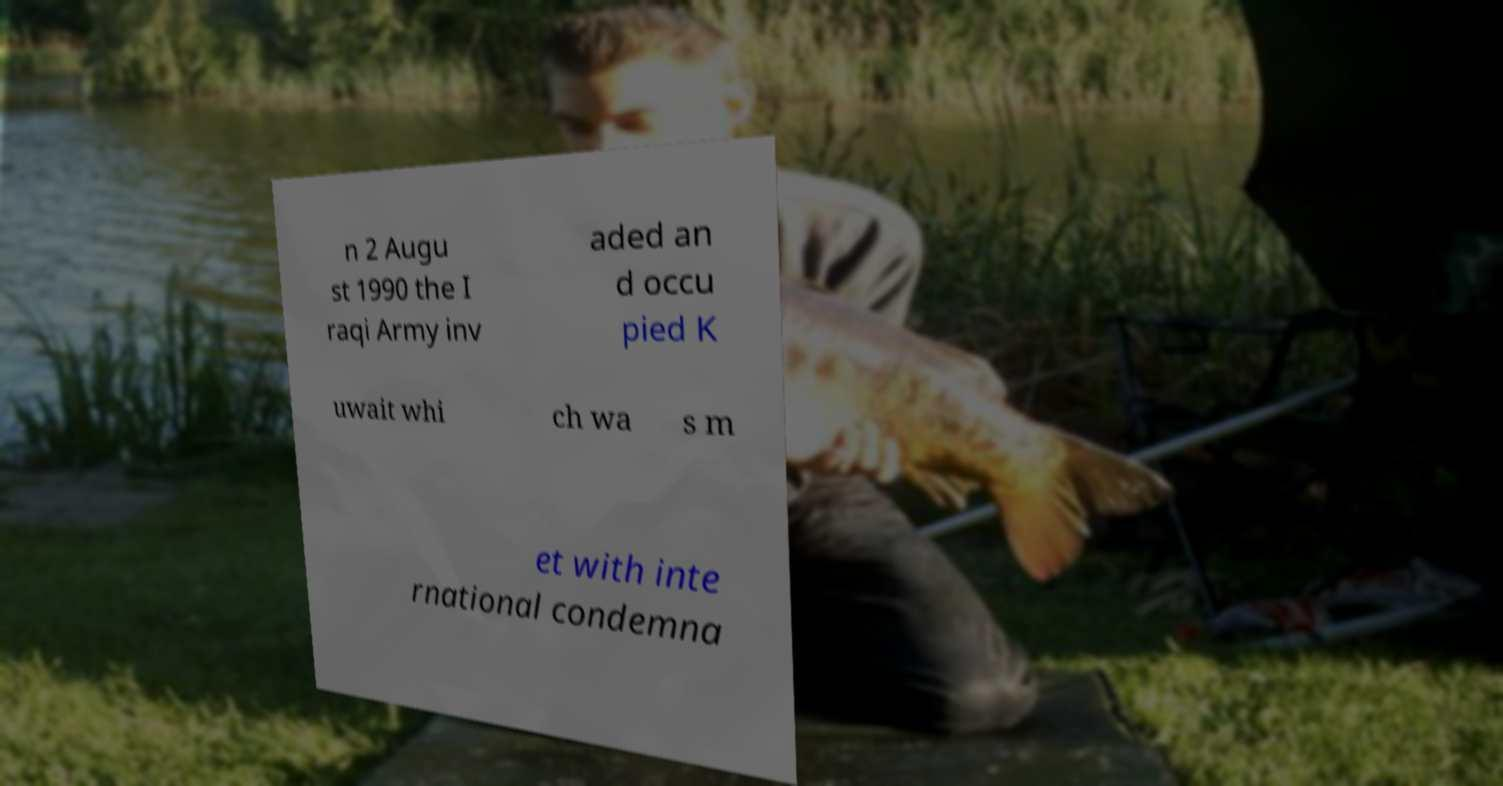For documentation purposes, I need the text within this image transcribed. Could you provide that? n 2 Augu st 1990 the I raqi Army inv aded an d occu pied K uwait whi ch wa s m et with inte rnational condemna 